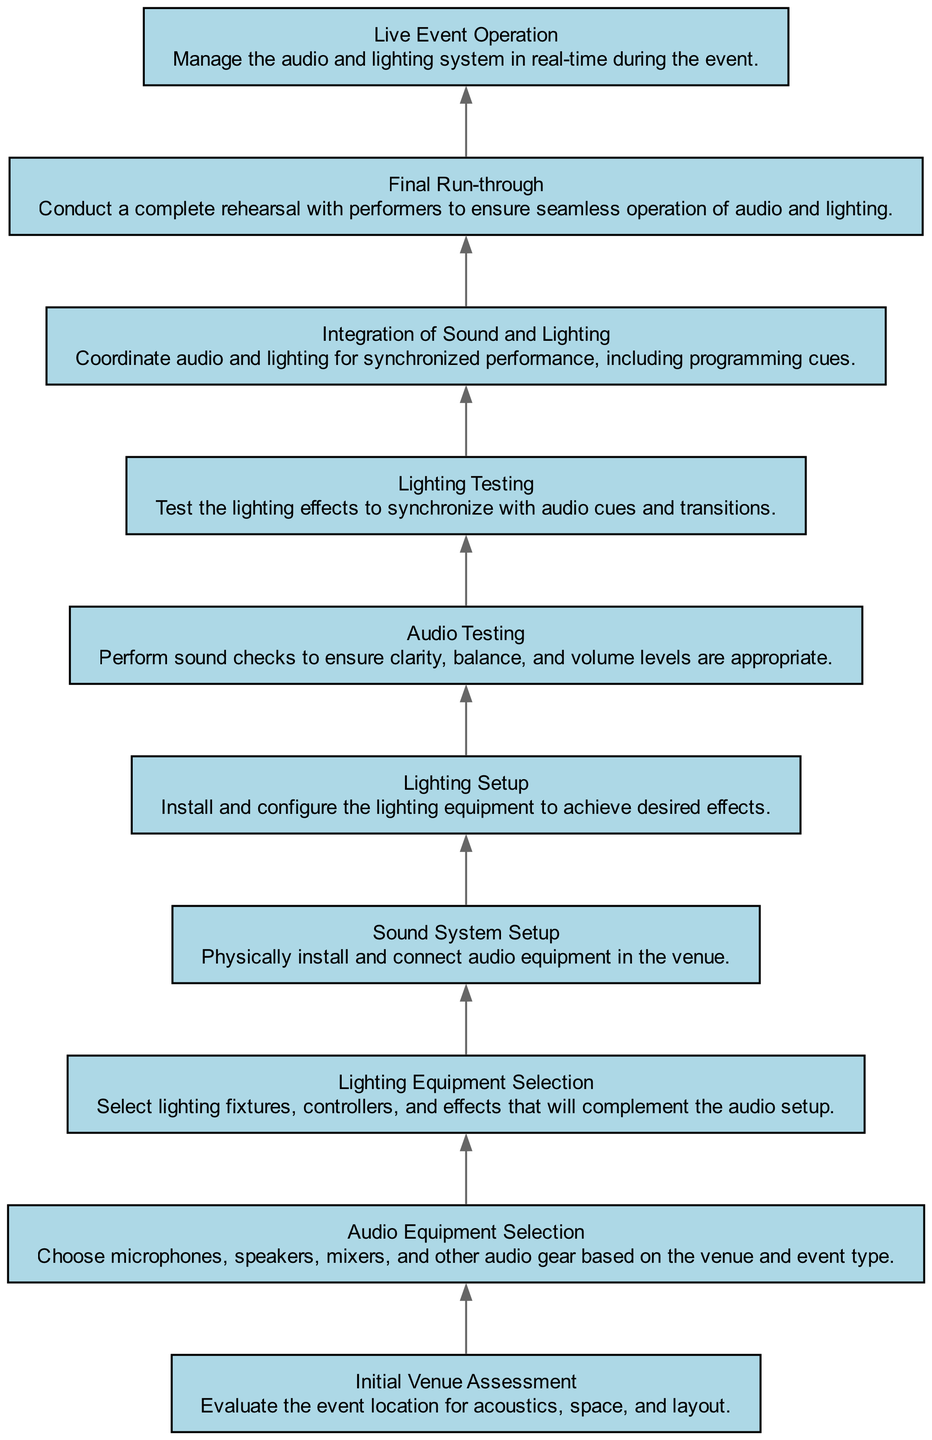What is the first step in the audio system setup process? The diagram indicates that "Initial Venue Assessment" is the first element. This means it is the starting point before any other steps are taken in the setup process.
Answer: Initial Venue Assessment How many steps are there in total in the diagram? By counting the elements listed in the diagram, there are ten distinct steps. Each represents a component of the audio system setup process as identified in the flow chart.
Answer: Ten What step comes immediately after "Audio Equipment Selection"? Referring to the diagram, "Lighting Equipment Selection" follows right after "Audio Equipment Selection" as the second step in the setup process.
Answer: Lighting Equipment Selection What is the last step before the live event operation? According to the flow of the diagram, the step "Final Run-through" occurs just before "Live Event Operation," indicating that it is a critical rehearsal step before executing the live event.
Answer: Final Run-through Which two steps focus on testing? The diagram outlines "Audio Testing" and "Lighting Testing" as the two steps that specifically address testing the systems. This illustrates a need for verification in both audio and lighting setups.
Answer: Audio Testing, Lighting Testing What is the relationship between "Integration of Sound and Lighting" and the steps that precede it? "Integration of Sound and Lighting" is dependent on the successful completion of both "Audio Testing" and "Lighting Testing." This indicates that both systems must be tested before they can be effectively integrated for the event.
Answer: It follows the testing steps Explain the role of "Sound System Setup" in relation to "Audio Equipment Selection." "Sound System Setup" represents the physical installation of audio equipment chosen in "Audio Equipment Selection." It is a direct application of the decisions made in the selection step, setting the stage for further testing.
Answer: Installation of selected audio equipment What comes right before "Audio Testing"? The diagram shows that after "Sound System Setup," the next step is "Audio Testing." This implies that the system must be physically set up before any audio testing can occur.
Answer: Sound System Setup Which step emphasizes the synchronization of audio cues with lighting effects? "Lighting Testing" highlights the act of synchronizing lighting with audio cues and transitions, ensuring that both systems work in harmony before the event.
Answer: Lighting Testing What is the primary focus of the "Live Event Operation" step? The primary focus of "Live Event Operation" centers on managing both audio and lighting systems in real-time, ensuring that everything runs smoothly during the actual event.
Answer: Managing in real-time 